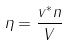Convert formula to latex. <formula><loc_0><loc_0><loc_500><loc_500>\eta = \frac { v ^ { * } n } { V }</formula> 